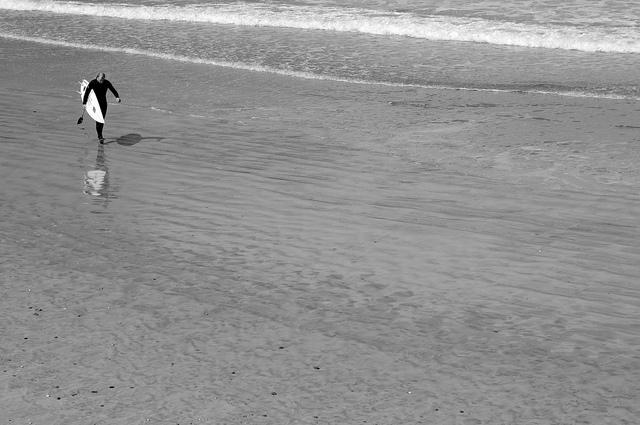What is the man riding?
Short answer required. Surfboard. What is the man doing?
Short answer required. Walking. What is this person carrying?
Answer briefly. Surfboard. What is reflected in the water?
Give a very brief answer. Surfer. Is the person alone?
Quick response, please. Yes. 